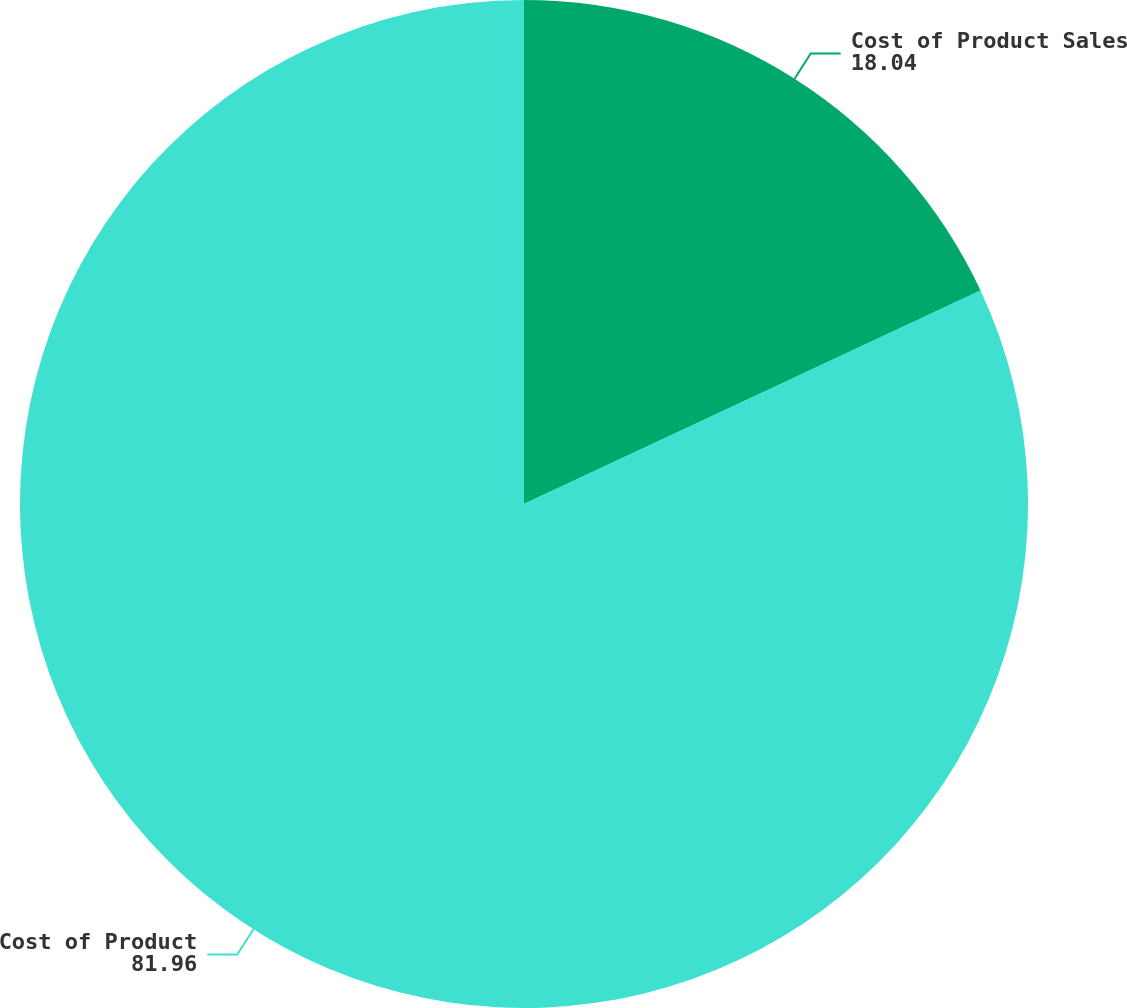Convert chart to OTSL. <chart><loc_0><loc_0><loc_500><loc_500><pie_chart><fcel>Cost of Product Sales<fcel>Cost of Product<nl><fcel>18.04%<fcel>81.96%<nl></chart> 